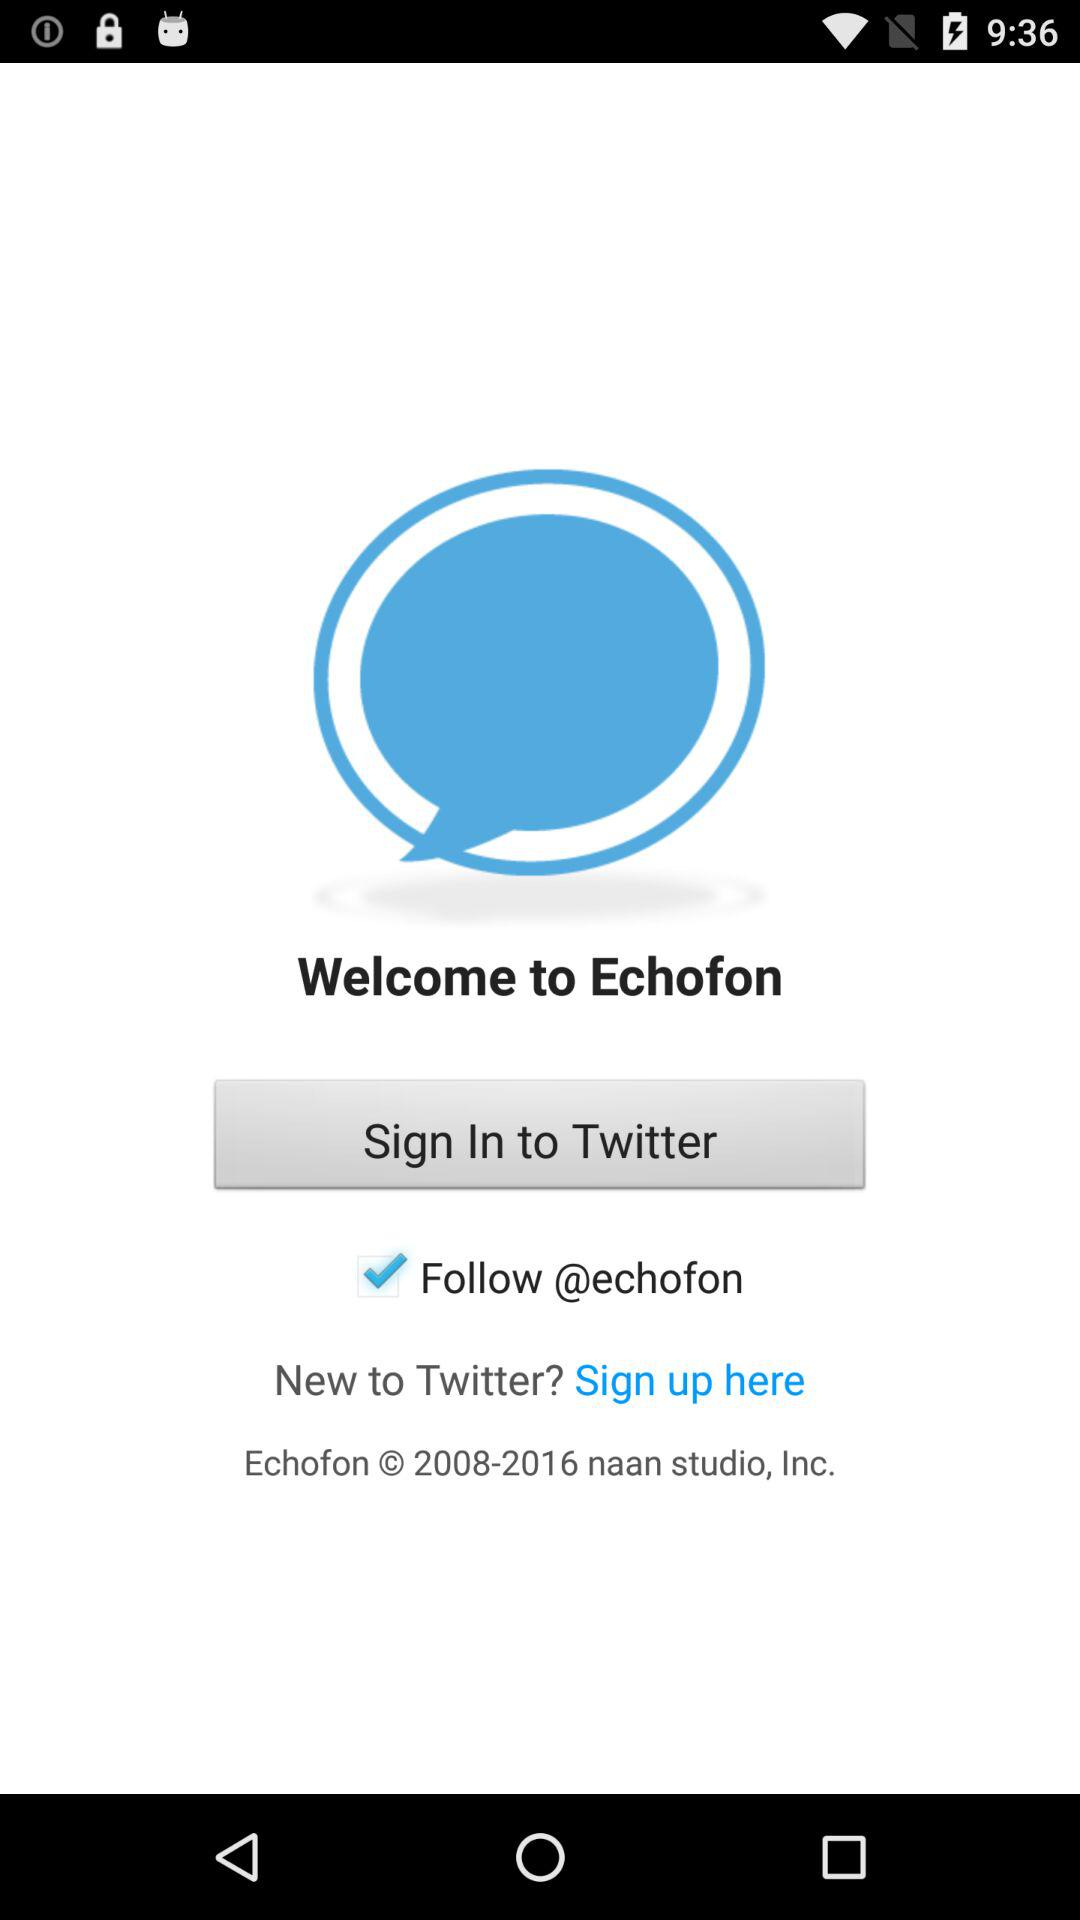How long does it take to sign in to "Twitter"?
When the provided information is insufficient, respond with <no answer>. <no answer> 